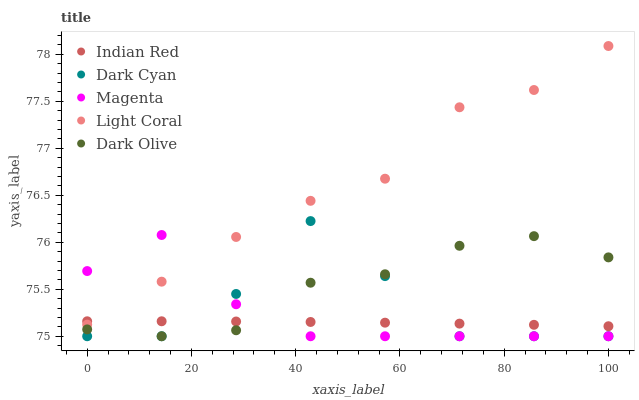Does Indian Red have the minimum area under the curve?
Answer yes or no. Yes. Does Light Coral have the maximum area under the curve?
Answer yes or no. Yes. Does Magenta have the minimum area under the curve?
Answer yes or no. No. Does Magenta have the maximum area under the curve?
Answer yes or no. No. Is Indian Red the smoothest?
Answer yes or no. Yes. Is Dark Cyan the roughest?
Answer yes or no. Yes. Is Light Coral the smoothest?
Answer yes or no. No. Is Light Coral the roughest?
Answer yes or no. No. Does Dark Cyan have the lowest value?
Answer yes or no. Yes. Does Light Coral have the lowest value?
Answer yes or no. No. Does Light Coral have the highest value?
Answer yes or no. Yes. Does Magenta have the highest value?
Answer yes or no. No. Is Dark Cyan less than Light Coral?
Answer yes or no. Yes. Is Light Coral greater than Dark Olive?
Answer yes or no. Yes. Does Magenta intersect Dark Cyan?
Answer yes or no. Yes. Is Magenta less than Dark Cyan?
Answer yes or no. No. Is Magenta greater than Dark Cyan?
Answer yes or no. No. Does Dark Cyan intersect Light Coral?
Answer yes or no. No. 